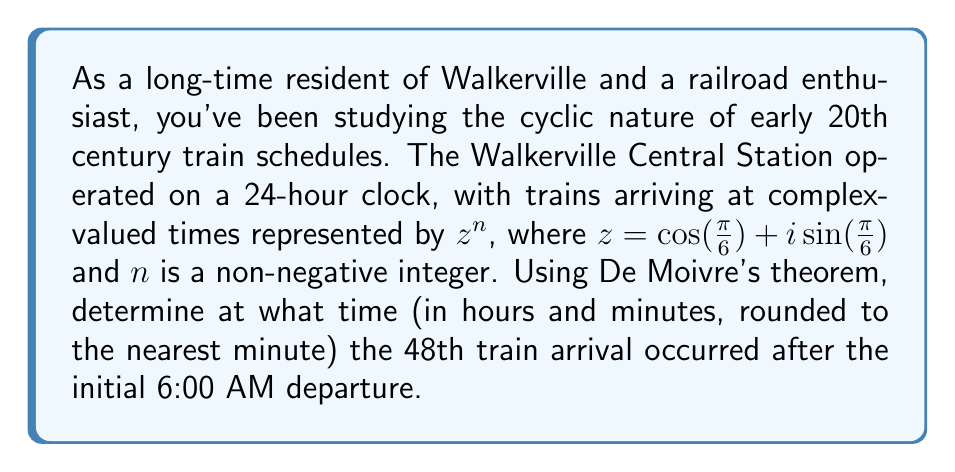Provide a solution to this math problem. Let's approach this step-by-step:

1) First, we need to understand what $z$ represents. Given $z = \cos(\frac{\pi}{6}) + i\sin(\frac{\pi}{6})$, this is a complex number on the unit circle, rotated $\frac{\pi}{6}$ radians (or 30°) counterclockwise from the positive real axis.

2) The initial departure is at 6:00 AM, which we can consider as our starting point (n = 0).

3) We're asked about the 48th train arrival, so we need to calculate $z^{48}$.

4) This is where De Moivre's theorem comes in handy. It states that for any real number $x$ and integer $n$:

   $$(\cos x + i \sin x)^n = \cos(nx) + i \sin(nx)$$

5) Applying this to our problem:

   $$z^{48} = (\cos(\frac{\pi}{6}) + i\sin(\frac{\pi}{6}))^{48} = \cos(\frac{48\pi}{6}) + i\sin(\frac{48\pi}{6})$$

6) Simplify $\frac{48\pi}{6} = 8\pi$

7) We know that $\cos(8\pi) = 1$ and $\sin(8\pi) = 0$, so:

   $$z^{48} = 1 + 0i = 1$$

8) This means that after 48 rotations, we're back at our starting point.

9) Each rotation represents $\frac{1}{12}$ of a full day (as $\frac{\pi}{6}$ is $\frac{1}{12}$ of a full circle).

10) So, 48 rotations represent 4 full days (48 ÷ 12 = 4).

11) Therefore, the 48th train will arrive at the same time as the initial departure: 6:00 AM, but 4 days later.
Answer: The 48th train arrival occurred at 6:00 AM, 4 days after the initial departure. 